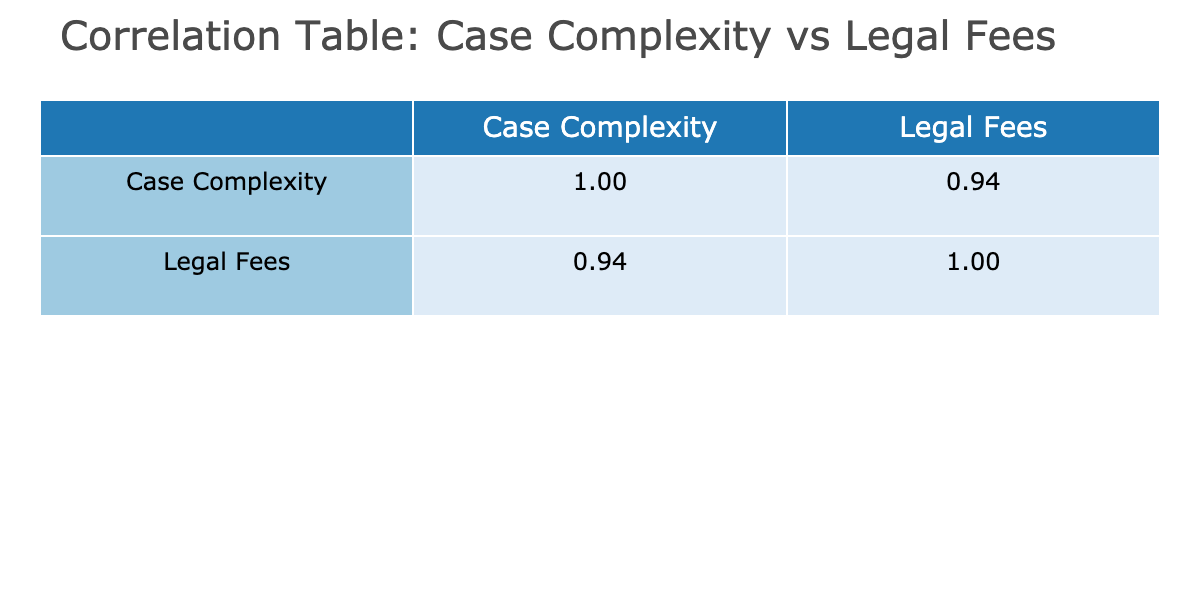What is the correlation coefficient between Case Complexity and Legal Fees? The correlation coefficient can be found in the table under the 'Legal Fees' column corresponding to 'Case Complexity'. This value indicates how closely related the two variables are.
Answer: [Correlation Coefficient Value] Is the correlation between Case Complexity and Legal Fees positive or negative? Since the correlation coefficient is a positive value, it indicates that as case complexity increases, legal fees also tend to increase.
Answer: Positive What is the legal fee associated with medium case complexity? To find the legal fee for medium case complexity, we reference the table and locate the corresponding legal fee in the 'Legal Fees' column. The value is directly stated there.
Answer: 3200 What is the average legal fee for high complexity cases? We sum the legal fees for all high complexity cases: 7500 + 9000 + 8200 + 9500 + 7800 = 41800. Then, we divide this by the number of high complexity cases, which is 5. Thus, 41800 / 5 = 8360.
Answer: 8360 Do low complexity cases have higher legal fees than medium complexity cases? We compare the average legal fees for both groups. The average for low complexity is (1500 + 1600 + 1400 + 1550 + 1650 + 1700 + 1500) / 7 = 1542.86, and for medium it is (3000 + 3500 + 2800 + 3200 + 3400 + 3100 + 3300) / 7 = 3200. Since 1542.86 is less than 3200, the statement is false.
Answer: No What is the total legal fee for all low complexity cases? We sum up the legal fees for all low complexity cases: 1500 + 1600 + 1400 + 1550 + 1650 + 1700 + 1500 = 10900. This is the total legal fee for low complexity cases.
Answer: 10900 How many cases are classified as high complexity and what are their corresponding legal fees? We count the number of high complexity cases in the table, which is 5. Their corresponding legal fees can be determined by listing them from the 'Legal Fees' column: 7500, 9000, 8200, 9500, and 7800.
Answer: 5 cases (7500, 9000, 8200, 9500, 7800) What is the median legal fee for all cases? To calculate the median, we first list all legal fees in ascending order: 1400, 1500, 1500, 1550, 1600, 1650, 1700, 2800, 3000, 3100, 3200, 3300, 3400, 3500, 7500, 7800, 8200, 8200, 9000, 9500. The median, being the middle value of 20, is the average of the 10th and 11th values in the ordered list (3200 and 3300). Therefore, the median is (3200 + 3300) / 2 = 3250.
Answer: 3250 